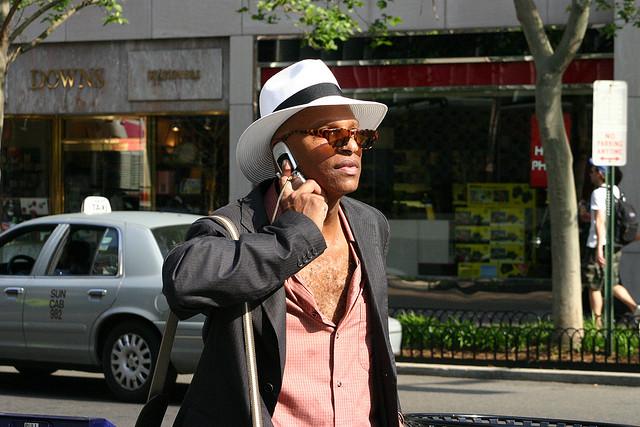What is across the street?
Concise answer only. Store. What cab company does the car represent?
Keep it brief. Sun cab. What colors are the man's jacket?
Concise answer only. Black. What do they call the clear white items they are holding?
Short answer required. Phone. Why carry an umbrella now?
Concise answer only. Sun. Is this man dressed casually?
Answer briefly. Yes. What is the color of the jacket?
Answer briefly. Black. What tall object is behind the man on the right?
Quick response, please. Tree. What is the person holding?
Keep it brief. Phone. Is this man wearing sunglasses?
Concise answer only. Yes. What is sticking up above the man's head?
Answer briefly. Hat. How many buttons are done up?
Keep it brief. 2. What is on the man's head?
Short answer required. Hat. What is the man holding?
Answer briefly. Cell phone. What is the sign of the man in the background?
Quick response, please. Downs. Why is the man standing there?
Give a very brief answer. Talking on phone. What is the man doing in the foreground?
Give a very brief answer. Talking on phone. What is the man watching?
Be succinct. Traffic. 